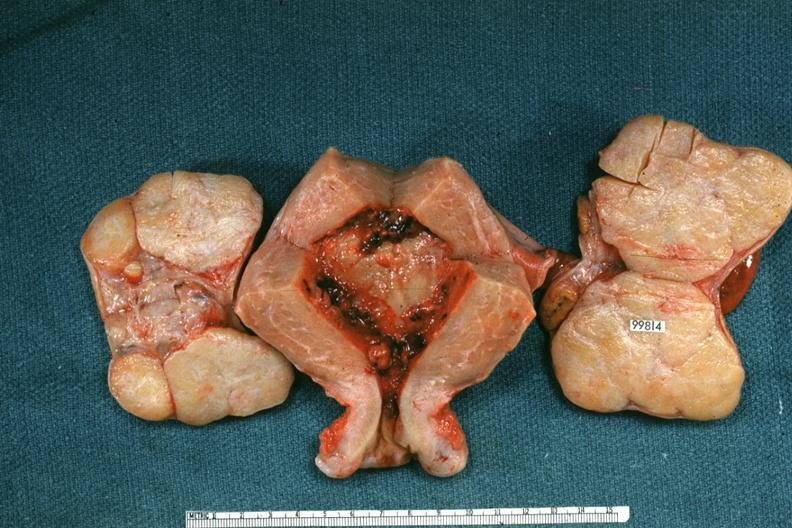what is present?
Answer the question using a single word or phrase. Female reproductive 